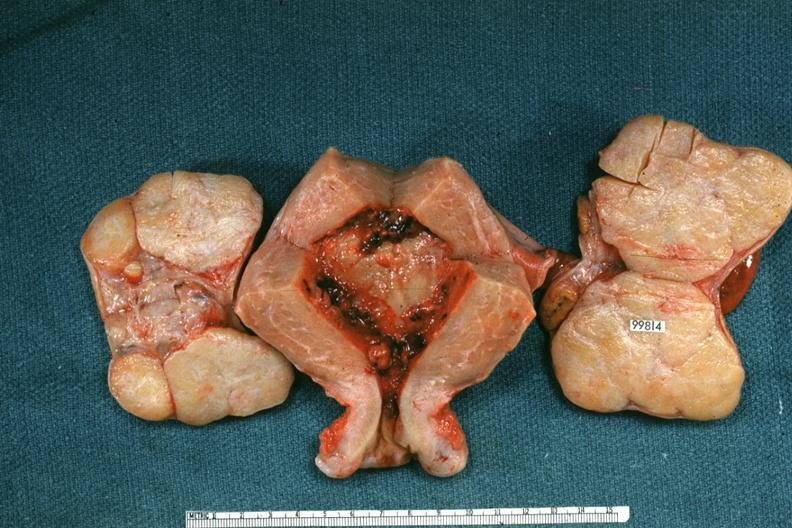what is present?
Answer the question using a single word or phrase. Female reproductive 